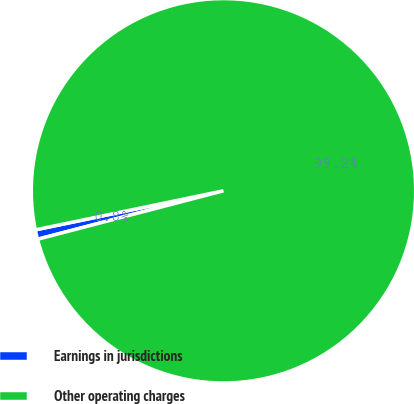Convert chart. <chart><loc_0><loc_0><loc_500><loc_500><pie_chart><fcel>Earnings in jurisdictions<fcel>Other operating charges<nl><fcel>0.8%<fcel>99.2%<nl></chart> 